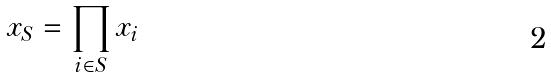<formula> <loc_0><loc_0><loc_500><loc_500>x _ { S } = \prod _ { i \in S } x _ { i }</formula> 